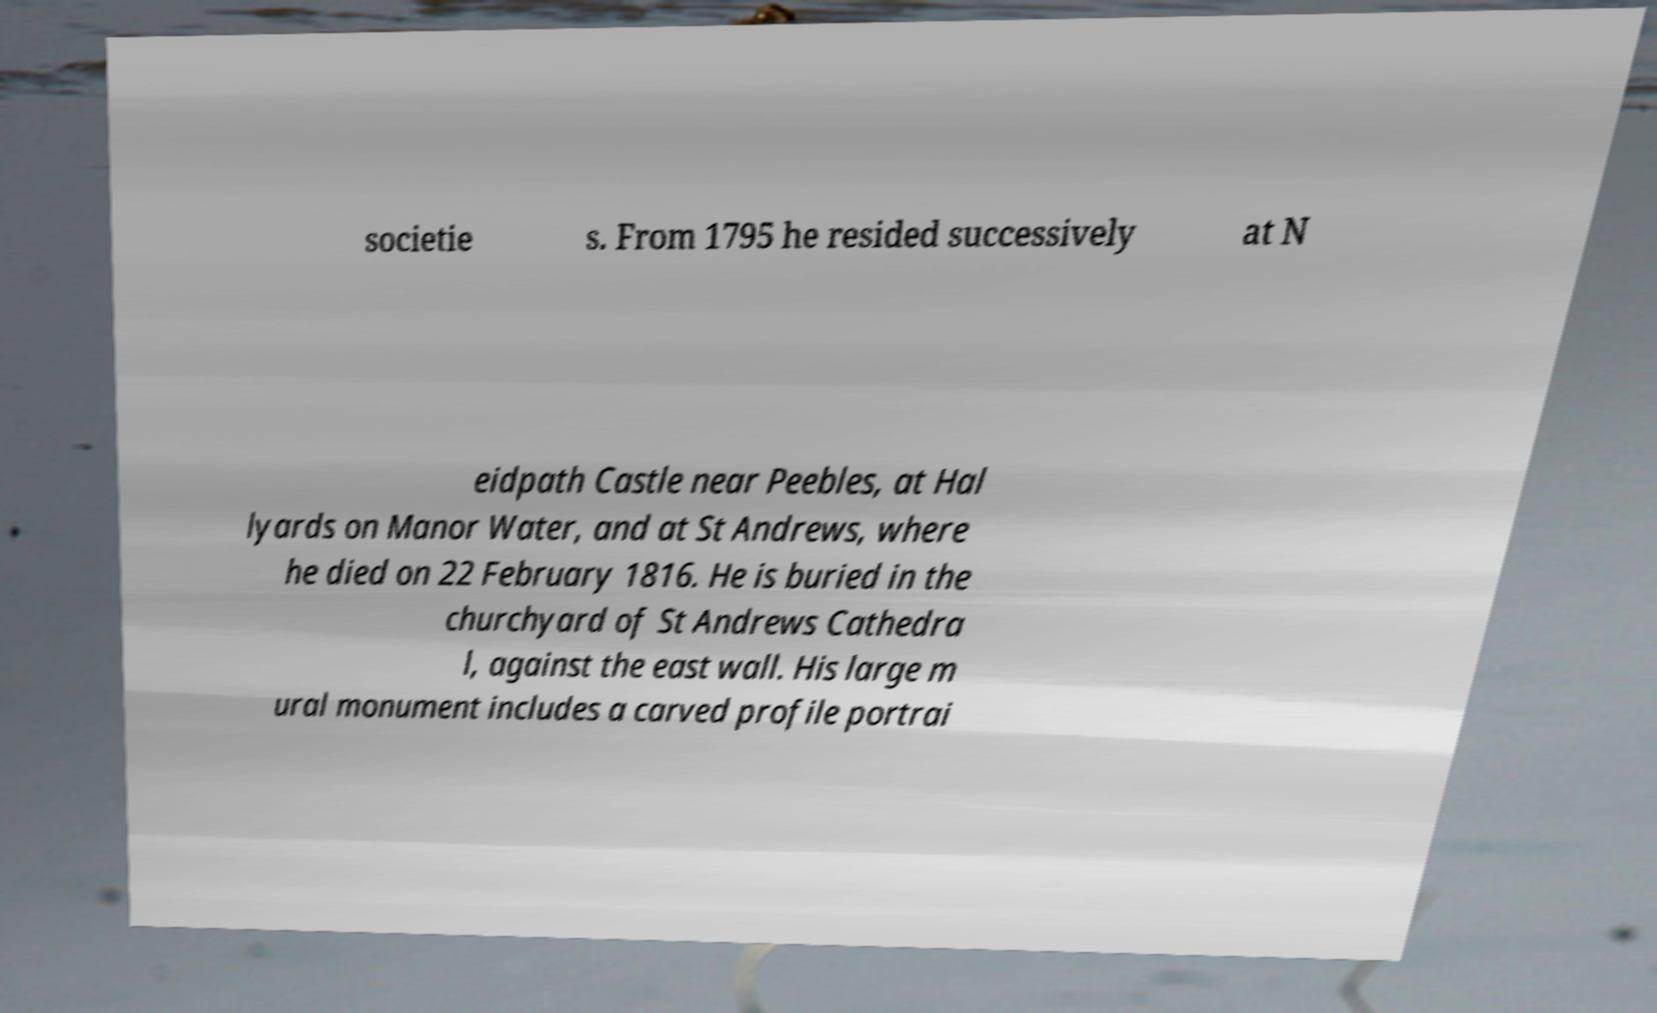Please identify and transcribe the text found in this image. societie s. From 1795 he resided successively at N eidpath Castle near Peebles, at Hal lyards on Manor Water, and at St Andrews, where he died on 22 February 1816. He is buried in the churchyard of St Andrews Cathedra l, against the east wall. His large m ural monument includes a carved profile portrai 